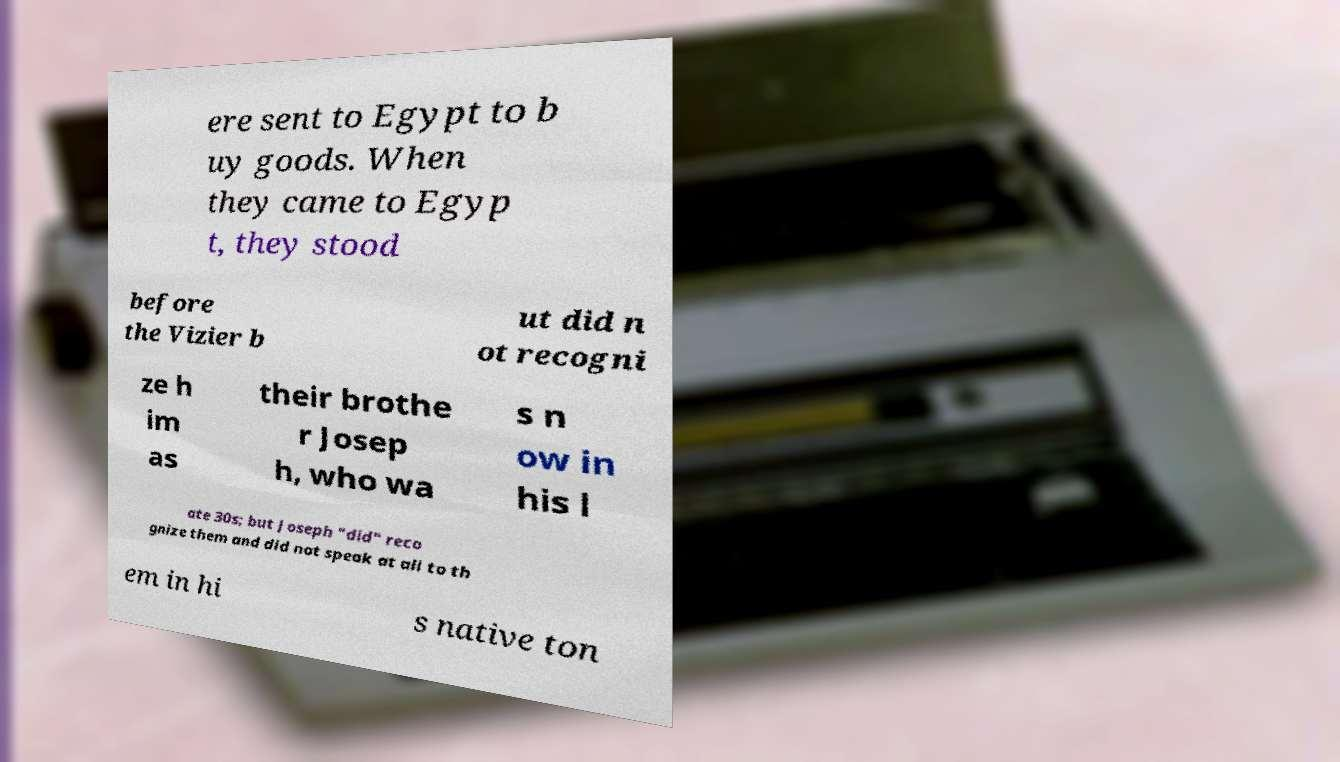I need the written content from this picture converted into text. Can you do that? ere sent to Egypt to b uy goods. When they came to Egyp t, they stood before the Vizier b ut did n ot recogni ze h im as their brothe r Josep h, who wa s n ow in his l ate 30s; but Joseph "did" reco gnize them and did not speak at all to th em in hi s native ton 